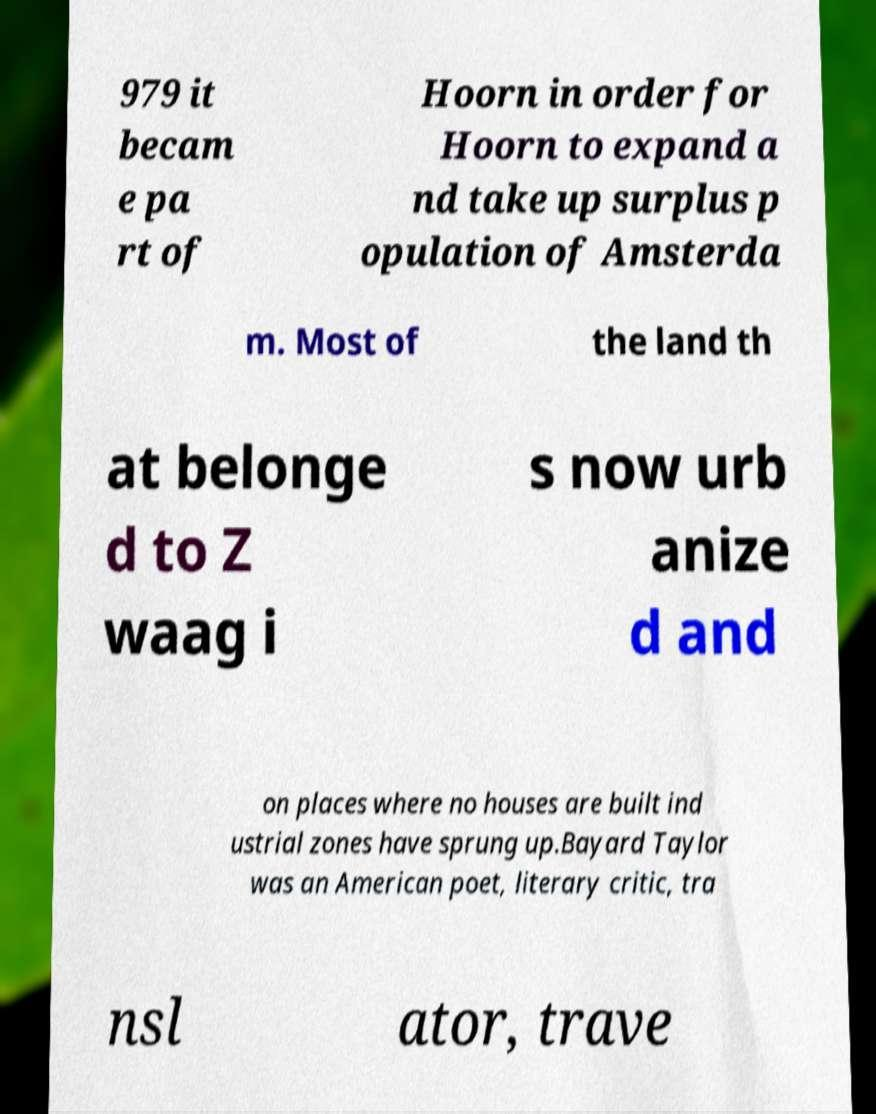Can you read and provide the text displayed in the image?This photo seems to have some interesting text. Can you extract and type it out for me? 979 it becam e pa rt of Hoorn in order for Hoorn to expand a nd take up surplus p opulation of Amsterda m. Most of the land th at belonge d to Z waag i s now urb anize d and on places where no houses are built ind ustrial zones have sprung up.Bayard Taylor was an American poet, literary critic, tra nsl ator, trave 